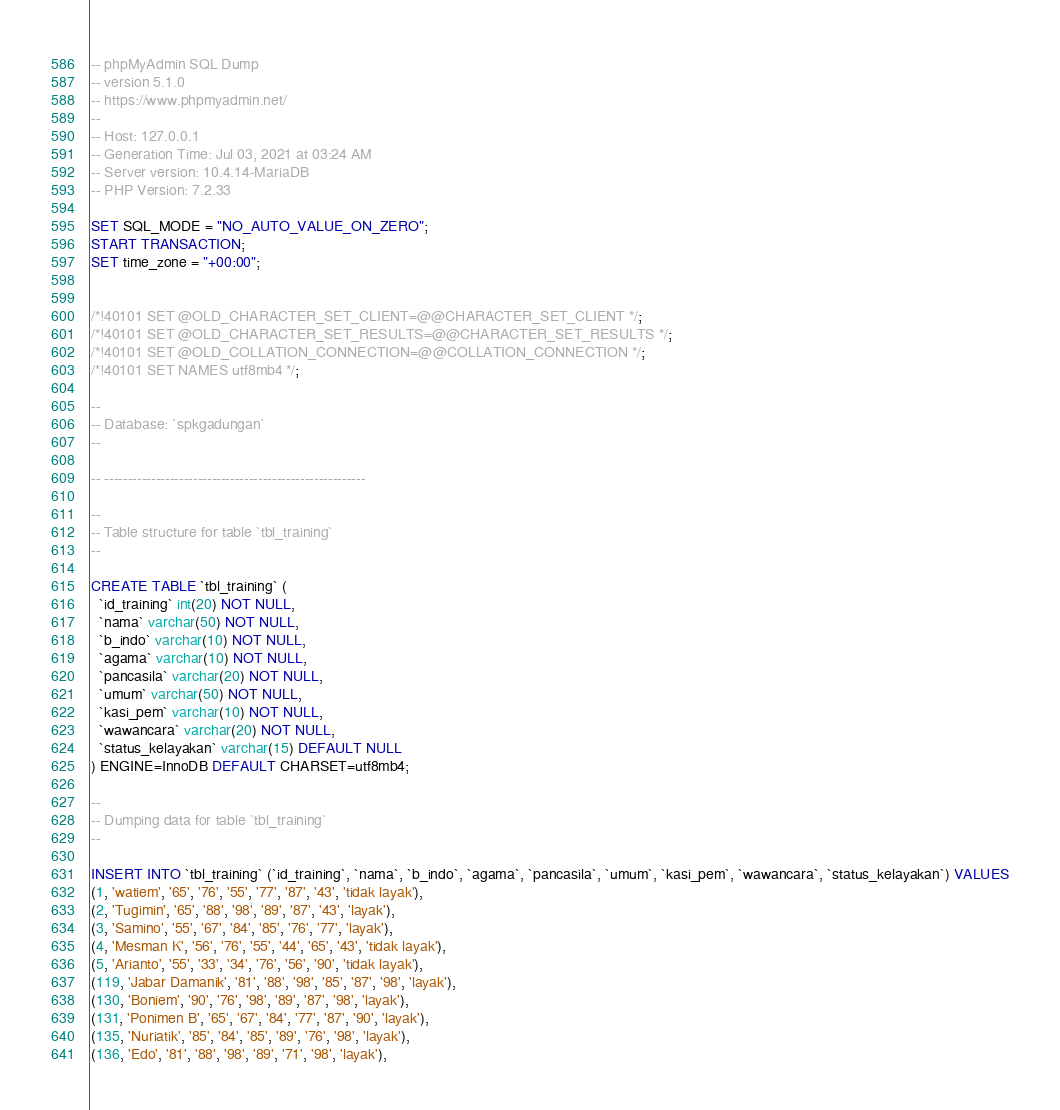<code> <loc_0><loc_0><loc_500><loc_500><_SQL_>-- phpMyAdmin SQL Dump
-- version 5.1.0
-- https://www.phpmyadmin.net/
--
-- Host: 127.0.0.1
-- Generation Time: Jul 03, 2021 at 03:24 AM
-- Server version: 10.4.14-MariaDB
-- PHP Version: 7.2.33

SET SQL_MODE = "NO_AUTO_VALUE_ON_ZERO";
START TRANSACTION;
SET time_zone = "+00:00";


/*!40101 SET @OLD_CHARACTER_SET_CLIENT=@@CHARACTER_SET_CLIENT */;
/*!40101 SET @OLD_CHARACTER_SET_RESULTS=@@CHARACTER_SET_RESULTS */;
/*!40101 SET @OLD_COLLATION_CONNECTION=@@COLLATION_CONNECTION */;
/*!40101 SET NAMES utf8mb4 */;

--
-- Database: `spkgadungan`
--

-- --------------------------------------------------------

--
-- Table structure for table `tbl_training`
--

CREATE TABLE `tbl_training` (
  `id_training` int(20) NOT NULL,
  `nama` varchar(50) NOT NULL,
  `b_indo` varchar(10) NOT NULL,
  `agama` varchar(10) NOT NULL,
  `pancasila` varchar(20) NOT NULL,
  `umum` varchar(50) NOT NULL,
  `kasi_pem` varchar(10) NOT NULL,
  `wawancara` varchar(20) NOT NULL,
  `status_kelayakan` varchar(15) DEFAULT NULL
) ENGINE=InnoDB DEFAULT CHARSET=utf8mb4;

--
-- Dumping data for table `tbl_training`
--

INSERT INTO `tbl_training` (`id_training`, `nama`, `b_indo`, `agama`, `pancasila`, `umum`, `kasi_pem`, `wawancara`, `status_kelayakan`) VALUES
(1, 'watiem', '65', '76', '55', '77', '87', '43', 'tidak layak'),
(2, 'Tugimin', '65', '88', '98', '89', '87', '43', 'layak'),
(3, 'Samino', '55', '67', '84', '85', '76', '77', 'layak'),
(4, 'Mesman K', '56', '76', '55', '44', '65', '43', 'tidak layak'),
(5, 'Arianto', '55', '33', '34', '76', '56', '90', 'tidak layak'),
(119, 'Jabar Damanik', '81', '88', '98', '85', '87', '98', 'layak'),
(130, 'Boniem', '90', '76', '98', '89', '87', '98', 'layak'),
(131, 'Ponimen B', '65', '67', '84', '77', '87', '90', 'layak'),
(135, 'Nuriatik', '85', '84', '85', '89', '76', '98', 'layak'),
(136, 'Edo', '81', '88', '98', '89', '71', '98', 'layak'),</code> 